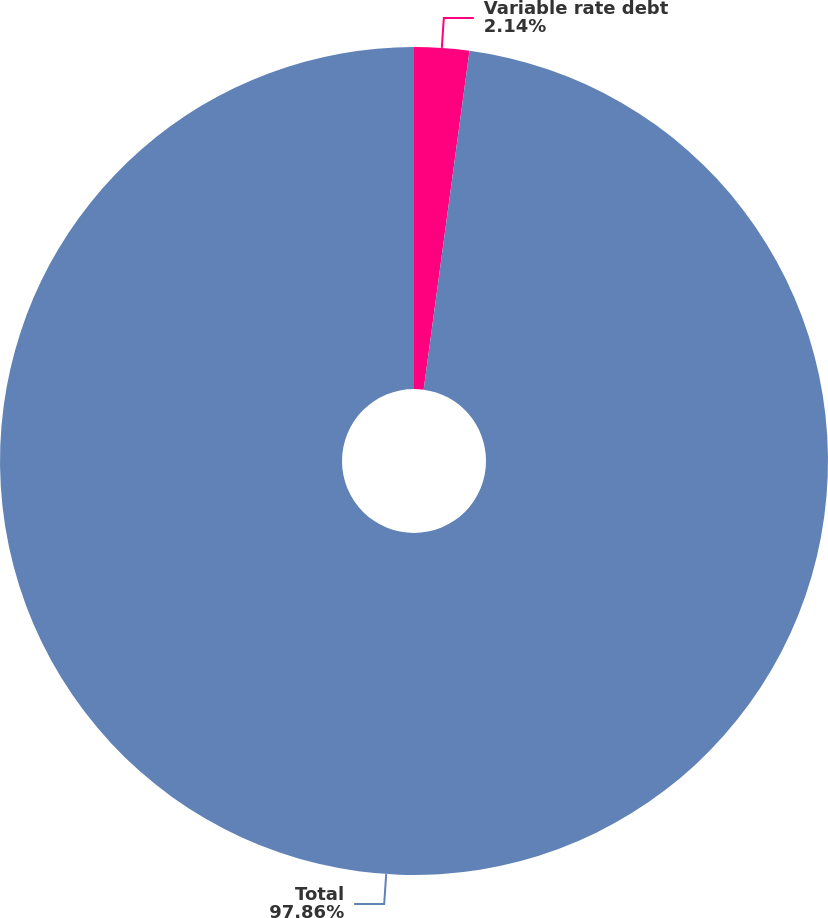<chart> <loc_0><loc_0><loc_500><loc_500><pie_chart><fcel>Variable rate debt<fcel>Total<nl><fcel>2.14%<fcel>97.86%<nl></chart> 